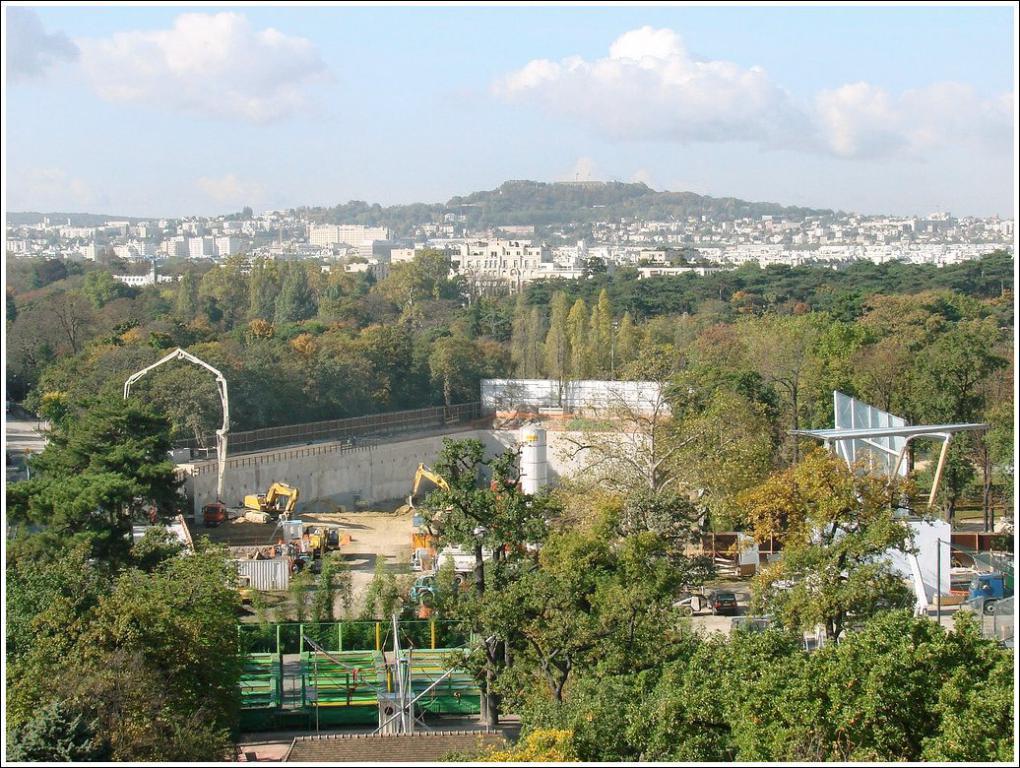In one or two sentences, can you explain what this image depicts? In the background we can see the clouds in the sky. In this picture we can see the thicket, trees, vehicles, excavators, poles, railing, objects and concrete tower. 